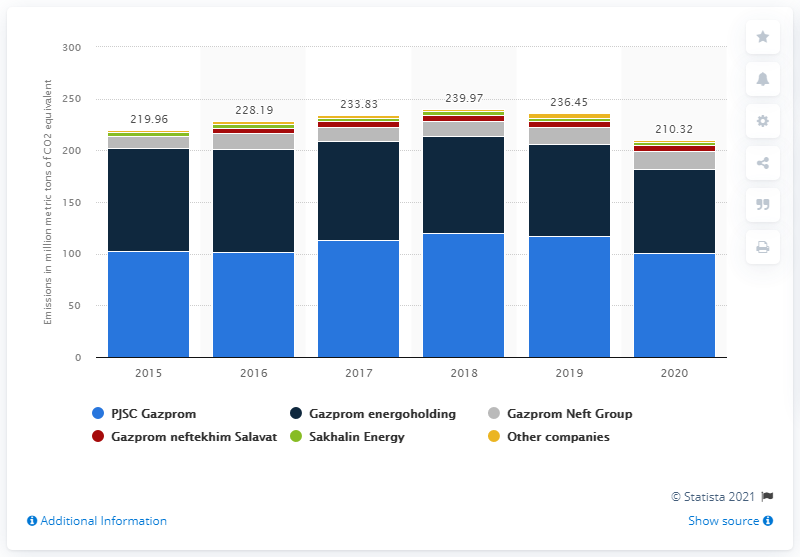Give some essential details in this illustration. In 2020, PJSC Gazprom emitted significantly less CO2 equivalent than the previous year, with a decrease of 16.04.. 